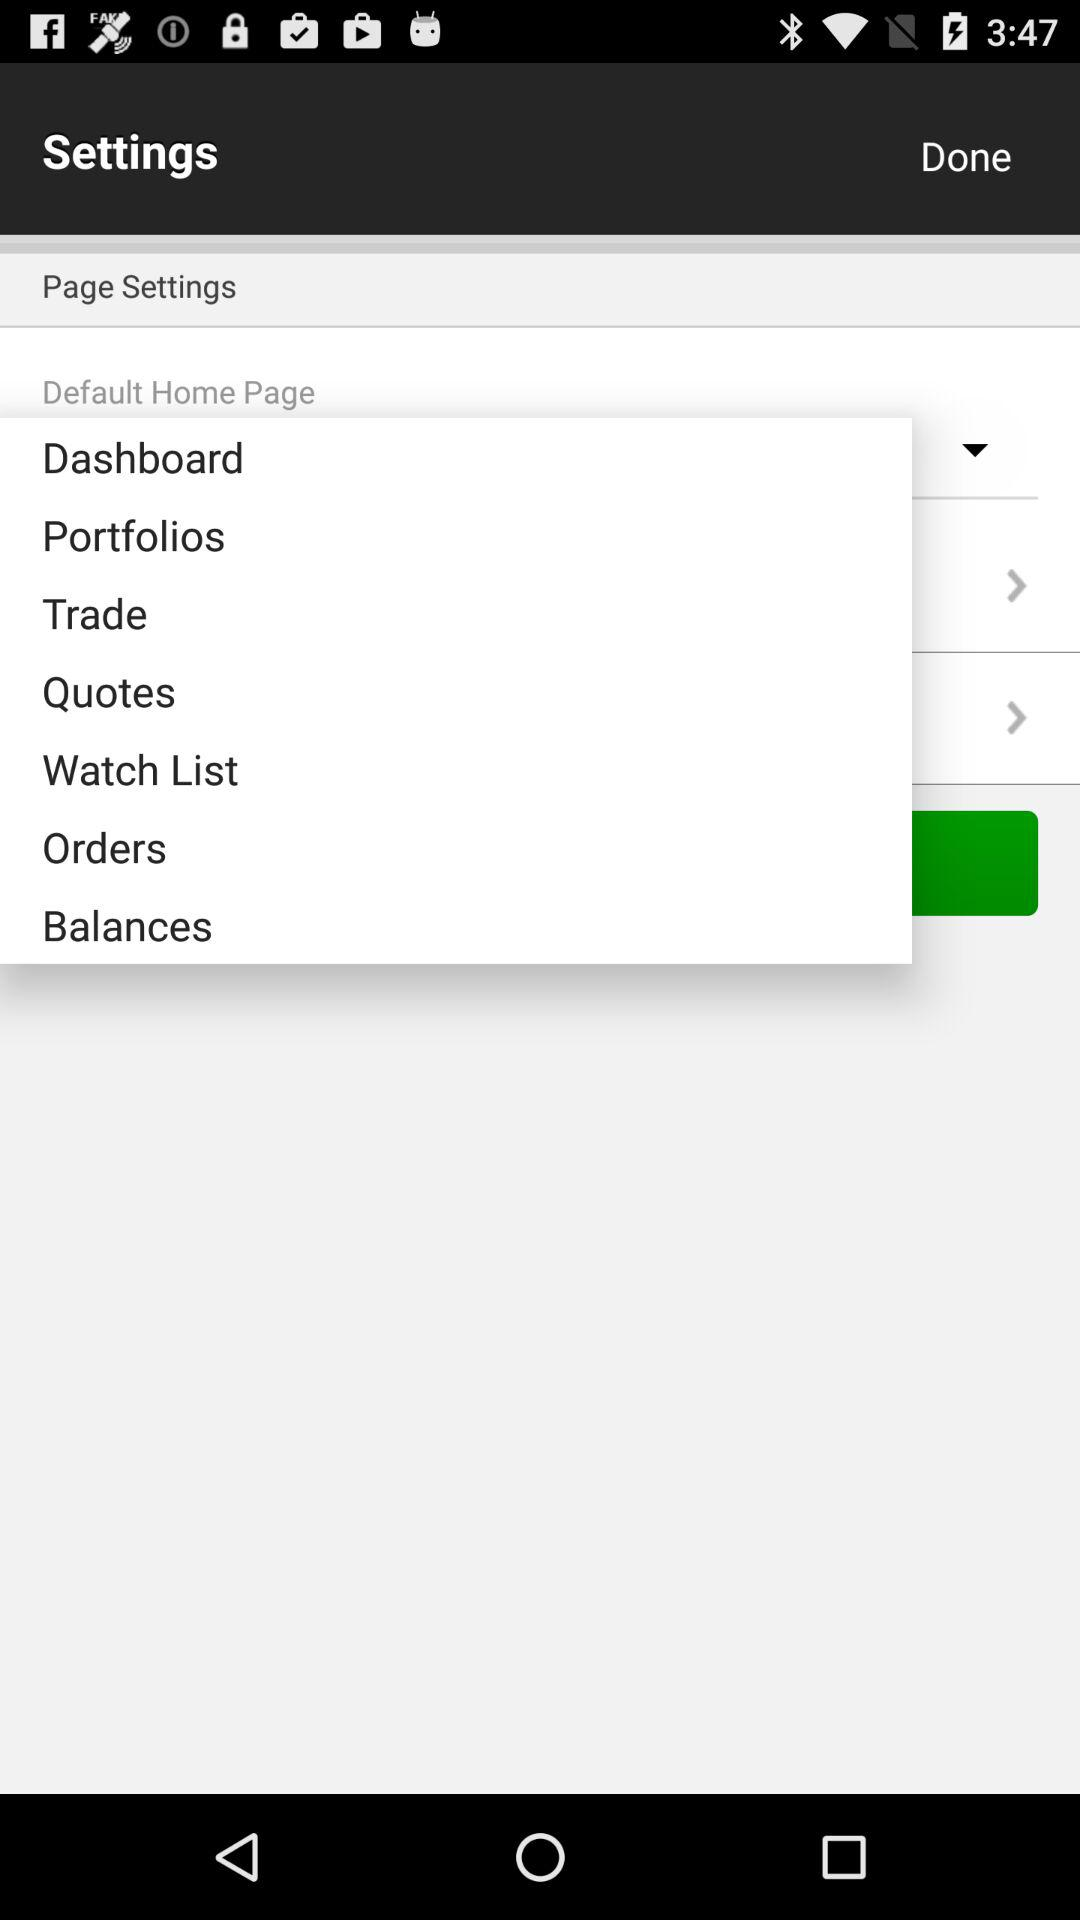Which version is it? It is version v 2.0. 